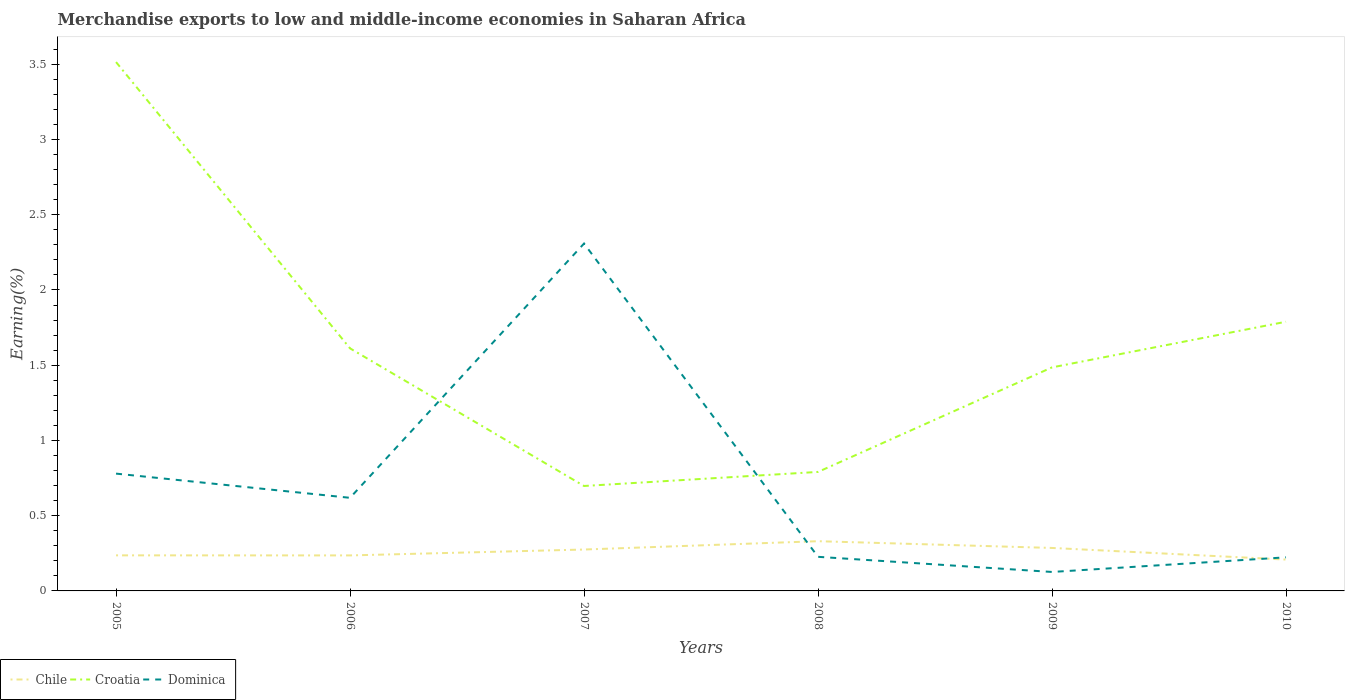How many different coloured lines are there?
Keep it short and to the point. 3. Does the line corresponding to Chile intersect with the line corresponding to Dominica?
Offer a terse response. Yes. Is the number of lines equal to the number of legend labels?
Provide a succinct answer. Yes. Across all years, what is the maximum percentage of amount earned from merchandise exports in Croatia?
Offer a very short reply. 0.7. What is the total percentage of amount earned from merchandise exports in Croatia in the graph?
Your response must be concise. -0.79. What is the difference between the highest and the second highest percentage of amount earned from merchandise exports in Chile?
Your answer should be compact. 0.12. What is the difference between the highest and the lowest percentage of amount earned from merchandise exports in Chile?
Give a very brief answer. 3. How many lines are there?
Keep it short and to the point. 3. Where does the legend appear in the graph?
Your response must be concise. Bottom left. What is the title of the graph?
Offer a very short reply. Merchandise exports to low and middle-income economies in Saharan Africa. Does "Turks and Caicos Islands" appear as one of the legend labels in the graph?
Provide a succinct answer. No. What is the label or title of the X-axis?
Offer a very short reply. Years. What is the label or title of the Y-axis?
Keep it short and to the point. Earning(%). What is the Earning(%) in Chile in 2005?
Your answer should be compact. 0.24. What is the Earning(%) in Croatia in 2005?
Your answer should be compact. 3.51. What is the Earning(%) of Dominica in 2005?
Offer a very short reply. 0.78. What is the Earning(%) in Chile in 2006?
Ensure brevity in your answer.  0.24. What is the Earning(%) of Croatia in 2006?
Offer a terse response. 1.61. What is the Earning(%) in Dominica in 2006?
Your answer should be compact. 0.62. What is the Earning(%) in Chile in 2007?
Give a very brief answer. 0.28. What is the Earning(%) in Croatia in 2007?
Offer a terse response. 0.7. What is the Earning(%) of Dominica in 2007?
Offer a terse response. 2.31. What is the Earning(%) in Chile in 2008?
Your answer should be compact. 0.33. What is the Earning(%) in Croatia in 2008?
Offer a very short reply. 0.79. What is the Earning(%) in Dominica in 2008?
Make the answer very short. 0.23. What is the Earning(%) of Chile in 2009?
Your answer should be very brief. 0.29. What is the Earning(%) in Croatia in 2009?
Your response must be concise. 1.49. What is the Earning(%) of Dominica in 2009?
Your answer should be very brief. 0.13. What is the Earning(%) in Chile in 2010?
Make the answer very short. 0.21. What is the Earning(%) in Croatia in 2010?
Your answer should be very brief. 1.79. What is the Earning(%) of Dominica in 2010?
Provide a short and direct response. 0.22. Across all years, what is the maximum Earning(%) in Chile?
Provide a succinct answer. 0.33. Across all years, what is the maximum Earning(%) in Croatia?
Offer a terse response. 3.51. Across all years, what is the maximum Earning(%) of Dominica?
Keep it short and to the point. 2.31. Across all years, what is the minimum Earning(%) of Chile?
Offer a very short reply. 0.21. Across all years, what is the minimum Earning(%) in Croatia?
Your answer should be very brief. 0.7. Across all years, what is the minimum Earning(%) of Dominica?
Ensure brevity in your answer.  0.13. What is the total Earning(%) in Chile in the graph?
Provide a short and direct response. 1.57. What is the total Earning(%) of Croatia in the graph?
Offer a very short reply. 9.89. What is the total Earning(%) of Dominica in the graph?
Offer a terse response. 4.28. What is the difference between the Earning(%) in Croatia in 2005 and that in 2006?
Keep it short and to the point. 1.9. What is the difference between the Earning(%) in Dominica in 2005 and that in 2006?
Your response must be concise. 0.16. What is the difference between the Earning(%) in Chile in 2005 and that in 2007?
Give a very brief answer. -0.04. What is the difference between the Earning(%) in Croatia in 2005 and that in 2007?
Ensure brevity in your answer.  2.82. What is the difference between the Earning(%) in Dominica in 2005 and that in 2007?
Ensure brevity in your answer.  -1.53. What is the difference between the Earning(%) of Chile in 2005 and that in 2008?
Offer a very short reply. -0.09. What is the difference between the Earning(%) in Croatia in 2005 and that in 2008?
Offer a very short reply. 2.72. What is the difference between the Earning(%) in Dominica in 2005 and that in 2008?
Offer a terse response. 0.55. What is the difference between the Earning(%) of Chile in 2005 and that in 2009?
Provide a succinct answer. -0.05. What is the difference between the Earning(%) in Croatia in 2005 and that in 2009?
Make the answer very short. 2.03. What is the difference between the Earning(%) in Dominica in 2005 and that in 2009?
Give a very brief answer. 0.65. What is the difference between the Earning(%) in Chile in 2005 and that in 2010?
Your response must be concise. 0.03. What is the difference between the Earning(%) in Croatia in 2005 and that in 2010?
Your answer should be compact. 1.73. What is the difference between the Earning(%) of Dominica in 2005 and that in 2010?
Your answer should be very brief. 0.56. What is the difference between the Earning(%) of Chile in 2006 and that in 2007?
Give a very brief answer. -0.04. What is the difference between the Earning(%) in Croatia in 2006 and that in 2007?
Give a very brief answer. 0.91. What is the difference between the Earning(%) in Dominica in 2006 and that in 2007?
Your answer should be compact. -1.69. What is the difference between the Earning(%) in Chile in 2006 and that in 2008?
Offer a very short reply. -0.09. What is the difference between the Earning(%) of Croatia in 2006 and that in 2008?
Make the answer very short. 0.82. What is the difference between the Earning(%) in Dominica in 2006 and that in 2008?
Your answer should be very brief. 0.39. What is the difference between the Earning(%) of Chile in 2006 and that in 2009?
Your answer should be very brief. -0.05. What is the difference between the Earning(%) of Croatia in 2006 and that in 2009?
Ensure brevity in your answer.  0.13. What is the difference between the Earning(%) of Dominica in 2006 and that in 2009?
Your answer should be compact. 0.49. What is the difference between the Earning(%) of Chile in 2006 and that in 2010?
Your answer should be very brief. 0.03. What is the difference between the Earning(%) in Croatia in 2006 and that in 2010?
Your response must be concise. -0.18. What is the difference between the Earning(%) of Dominica in 2006 and that in 2010?
Your response must be concise. 0.4. What is the difference between the Earning(%) of Chile in 2007 and that in 2008?
Provide a short and direct response. -0.06. What is the difference between the Earning(%) of Croatia in 2007 and that in 2008?
Give a very brief answer. -0.09. What is the difference between the Earning(%) of Dominica in 2007 and that in 2008?
Your answer should be very brief. 2.08. What is the difference between the Earning(%) in Chile in 2007 and that in 2009?
Ensure brevity in your answer.  -0.01. What is the difference between the Earning(%) in Croatia in 2007 and that in 2009?
Keep it short and to the point. -0.79. What is the difference between the Earning(%) of Dominica in 2007 and that in 2009?
Your answer should be very brief. 2.18. What is the difference between the Earning(%) in Chile in 2007 and that in 2010?
Offer a terse response. 0.07. What is the difference between the Earning(%) in Croatia in 2007 and that in 2010?
Your answer should be compact. -1.09. What is the difference between the Earning(%) in Dominica in 2007 and that in 2010?
Ensure brevity in your answer.  2.09. What is the difference between the Earning(%) in Chile in 2008 and that in 2009?
Make the answer very short. 0.04. What is the difference between the Earning(%) of Croatia in 2008 and that in 2009?
Offer a very short reply. -0.69. What is the difference between the Earning(%) in Dominica in 2008 and that in 2009?
Your answer should be very brief. 0.1. What is the difference between the Earning(%) of Chile in 2008 and that in 2010?
Offer a very short reply. 0.12. What is the difference between the Earning(%) in Croatia in 2008 and that in 2010?
Ensure brevity in your answer.  -1. What is the difference between the Earning(%) in Dominica in 2008 and that in 2010?
Your answer should be very brief. 0. What is the difference between the Earning(%) of Chile in 2009 and that in 2010?
Your answer should be very brief. 0.08. What is the difference between the Earning(%) of Croatia in 2009 and that in 2010?
Give a very brief answer. -0.3. What is the difference between the Earning(%) of Dominica in 2009 and that in 2010?
Give a very brief answer. -0.1. What is the difference between the Earning(%) of Chile in 2005 and the Earning(%) of Croatia in 2006?
Your response must be concise. -1.38. What is the difference between the Earning(%) in Chile in 2005 and the Earning(%) in Dominica in 2006?
Make the answer very short. -0.38. What is the difference between the Earning(%) in Croatia in 2005 and the Earning(%) in Dominica in 2006?
Make the answer very short. 2.9. What is the difference between the Earning(%) in Chile in 2005 and the Earning(%) in Croatia in 2007?
Provide a succinct answer. -0.46. What is the difference between the Earning(%) of Chile in 2005 and the Earning(%) of Dominica in 2007?
Provide a short and direct response. -2.07. What is the difference between the Earning(%) of Croatia in 2005 and the Earning(%) of Dominica in 2007?
Ensure brevity in your answer.  1.21. What is the difference between the Earning(%) in Chile in 2005 and the Earning(%) in Croatia in 2008?
Your answer should be very brief. -0.55. What is the difference between the Earning(%) of Chile in 2005 and the Earning(%) of Dominica in 2008?
Make the answer very short. 0.01. What is the difference between the Earning(%) of Croatia in 2005 and the Earning(%) of Dominica in 2008?
Your answer should be compact. 3.29. What is the difference between the Earning(%) in Chile in 2005 and the Earning(%) in Croatia in 2009?
Offer a terse response. -1.25. What is the difference between the Earning(%) in Chile in 2005 and the Earning(%) in Dominica in 2009?
Give a very brief answer. 0.11. What is the difference between the Earning(%) in Croatia in 2005 and the Earning(%) in Dominica in 2009?
Provide a short and direct response. 3.39. What is the difference between the Earning(%) of Chile in 2005 and the Earning(%) of Croatia in 2010?
Your answer should be very brief. -1.55. What is the difference between the Earning(%) of Chile in 2005 and the Earning(%) of Dominica in 2010?
Your answer should be very brief. 0.01. What is the difference between the Earning(%) of Croatia in 2005 and the Earning(%) of Dominica in 2010?
Ensure brevity in your answer.  3.29. What is the difference between the Earning(%) in Chile in 2006 and the Earning(%) in Croatia in 2007?
Provide a short and direct response. -0.46. What is the difference between the Earning(%) of Chile in 2006 and the Earning(%) of Dominica in 2007?
Provide a succinct answer. -2.07. What is the difference between the Earning(%) of Croatia in 2006 and the Earning(%) of Dominica in 2007?
Your response must be concise. -0.7. What is the difference between the Earning(%) in Chile in 2006 and the Earning(%) in Croatia in 2008?
Offer a very short reply. -0.55. What is the difference between the Earning(%) in Chile in 2006 and the Earning(%) in Dominica in 2008?
Your answer should be compact. 0.01. What is the difference between the Earning(%) in Croatia in 2006 and the Earning(%) in Dominica in 2008?
Make the answer very short. 1.39. What is the difference between the Earning(%) in Chile in 2006 and the Earning(%) in Croatia in 2009?
Provide a short and direct response. -1.25. What is the difference between the Earning(%) of Chile in 2006 and the Earning(%) of Dominica in 2009?
Give a very brief answer. 0.11. What is the difference between the Earning(%) of Croatia in 2006 and the Earning(%) of Dominica in 2009?
Your answer should be very brief. 1.49. What is the difference between the Earning(%) of Chile in 2006 and the Earning(%) of Croatia in 2010?
Provide a succinct answer. -1.55. What is the difference between the Earning(%) of Chile in 2006 and the Earning(%) of Dominica in 2010?
Offer a very short reply. 0.01. What is the difference between the Earning(%) in Croatia in 2006 and the Earning(%) in Dominica in 2010?
Offer a very short reply. 1.39. What is the difference between the Earning(%) of Chile in 2007 and the Earning(%) of Croatia in 2008?
Your answer should be compact. -0.52. What is the difference between the Earning(%) of Chile in 2007 and the Earning(%) of Dominica in 2008?
Your response must be concise. 0.05. What is the difference between the Earning(%) of Croatia in 2007 and the Earning(%) of Dominica in 2008?
Provide a short and direct response. 0.47. What is the difference between the Earning(%) in Chile in 2007 and the Earning(%) in Croatia in 2009?
Make the answer very short. -1.21. What is the difference between the Earning(%) in Chile in 2007 and the Earning(%) in Dominica in 2009?
Provide a succinct answer. 0.15. What is the difference between the Earning(%) of Croatia in 2007 and the Earning(%) of Dominica in 2009?
Keep it short and to the point. 0.57. What is the difference between the Earning(%) of Chile in 2007 and the Earning(%) of Croatia in 2010?
Give a very brief answer. -1.51. What is the difference between the Earning(%) in Chile in 2007 and the Earning(%) in Dominica in 2010?
Keep it short and to the point. 0.05. What is the difference between the Earning(%) in Croatia in 2007 and the Earning(%) in Dominica in 2010?
Make the answer very short. 0.47. What is the difference between the Earning(%) in Chile in 2008 and the Earning(%) in Croatia in 2009?
Offer a very short reply. -1.16. What is the difference between the Earning(%) in Chile in 2008 and the Earning(%) in Dominica in 2009?
Ensure brevity in your answer.  0.2. What is the difference between the Earning(%) in Croatia in 2008 and the Earning(%) in Dominica in 2009?
Offer a very short reply. 0.66. What is the difference between the Earning(%) of Chile in 2008 and the Earning(%) of Croatia in 2010?
Offer a very short reply. -1.46. What is the difference between the Earning(%) of Chile in 2008 and the Earning(%) of Dominica in 2010?
Your answer should be very brief. 0.11. What is the difference between the Earning(%) of Croatia in 2008 and the Earning(%) of Dominica in 2010?
Make the answer very short. 0.57. What is the difference between the Earning(%) of Chile in 2009 and the Earning(%) of Croatia in 2010?
Keep it short and to the point. -1.5. What is the difference between the Earning(%) of Chile in 2009 and the Earning(%) of Dominica in 2010?
Provide a short and direct response. 0.06. What is the difference between the Earning(%) in Croatia in 2009 and the Earning(%) in Dominica in 2010?
Make the answer very short. 1.26. What is the average Earning(%) of Chile per year?
Your answer should be very brief. 0.26. What is the average Earning(%) in Croatia per year?
Your response must be concise. 1.65. What is the average Earning(%) of Dominica per year?
Offer a terse response. 0.71. In the year 2005, what is the difference between the Earning(%) of Chile and Earning(%) of Croatia?
Ensure brevity in your answer.  -3.28. In the year 2005, what is the difference between the Earning(%) of Chile and Earning(%) of Dominica?
Provide a short and direct response. -0.54. In the year 2005, what is the difference between the Earning(%) of Croatia and Earning(%) of Dominica?
Your answer should be very brief. 2.74. In the year 2006, what is the difference between the Earning(%) in Chile and Earning(%) in Croatia?
Give a very brief answer. -1.38. In the year 2006, what is the difference between the Earning(%) in Chile and Earning(%) in Dominica?
Keep it short and to the point. -0.38. In the year 2007, what is the difference between the Earning(%) in Chile and Earning(%) in Croatia?
Offer a terse response. -0.42. In the year 2007, what is the difference between the Earning(%) in Chile and Earning(%) in Dominica?
Provide a succinct answer. -2.03. In the year 2007, what is the difference between the Earning(%) in Croatia and Earning(%) in Dominica?
Provide a succinct answer. -1.61. In the year 2008, what is the difference between the Earning(%) of Chile and Earning(%) of Croatia?
Your answer should be compact. -0.46. In the year 2008, what is the difference between the Earning(%) in Chile and Earning(%) in Dominica?
Provide a succinct answer. 0.1. In the year 2008, what is the difference between the Earning(%) of Croatia and Earning(%) of Dominica?
Give a very brief answer. 0.56. In the year 2009, what is the difference between the Earning(%) in Chile and Earning(%) in Croatia?
Your answer should be very brief. -1.2. In the year 2009, what is the difference between the Earning(%) in Chile and Earning(%) in Dominica?
Provide a short and direct response. 0.16. In the year 2009, what is the difference between the Earning(%) of Croatia and Earning(%) of Dominica?
Your answer should be compact. 1.36. In the year 2010, what is the difference between the Earning(%) in Chile and Earning(%) in Croatia?
Offer a terse response. -1.58. In the year 2010, what is the difference between the Earning(%) in Chile and Earning(%) in Dominica?
Ensure brevity in your answer.  -0.01. In the year 2010, what is the difference between the Earning(%) of Croatia and Earning(%) of Dominica?
Your answer should be compact. 1.57. What is the ratio of the Earning(%) of Chile in 2005 to that in 2006?
Your answer should be compact. 1. What is the ratio of the Earning(%) of Croatia in 2005 to that in 2006?
Keep it short and to the point. 2.18. What is the ratio of the Earning(%) of Dominica in 2005 to that in 2006?
Make the answer very short. 1.26. What is the ratio of the Earning(%) of Chile in 2005 to that in 2007?
Your answer should be compact. 0.86. What is the ratio of the Earning(%) of Croatia in 2005 to that in 2007?
Your answer should be very brief. 5.04. What is the ratio of the Earning(%) of Dominica in 2005 to that in 2007?
Ensure brevity in your answer.  0.34. What is the ratio of the Earning(%) in Chile in 2005 to that in 2008?
Provide a short and direct response. 0.72. What is the ratio of the Earning(%) in Croatia in 2005 to that in 2008?
Offer a terse response. 4.44. What is the ratio of the Earning(%) of Dominica in 2005 to that in 2008?
Provide a short and direct response. 3.44. What is the ratio of the Earning(%) in Chile in 2005 to that in 2009?
Give a very brief answer. 0.83. What is the ratio of the Earning(%) in Croatia in 2005 to that in 2009?
Keep it short and to the point. 2.37. What is the ratio of the Earning(%) in Dominica in 2005 to that in 2009?
Offer a very short reply. 6.19. What is the ratio of the Earning(%) in Chile in 2005 to that in 2010?
Give a very brief answer. 1.13. What is the ratio of the Earning(%) of Croatia in 2005 to that in 2010?
Offer a very short reply. 1.96. What is the ratio of the Earning(%) of Dominica in 2005 to that in 2010?
Keep it short and to the point. 3.49. What is the ratio of the Earning(%) in Chile in 2006 to that in 2007?
Offer a very short reply. 0.86. What is the ratio of the Earning(%) of Croatia in 2006 to that in 2007?
Keep it short and to the point. 2.31. What is the ratio of the Earning(%) in Dominica in 2006 to that in 2007?
Your answer should be very brief. 0.27. What is the ratio of the Earning(%) of Chile in 2006 to that in 2008?
Provide a succinct answer. 0.71. What is the ratio of the Earning(%) in Croatia in 2006 to that in 2008?
Offer a very short reply. 2.04. What is the ratio of the Earning(%) in Dominica in 2006 to that in 2008?
Provide a succinct answer. 2.73. What is the ratio of the Earning(%) in Chile in 2006 to that in 2009?
Ensure brevity in your answer.  0.83. What is the ratio of the Earning(%) of Croatia in 2006 to that in 2009?
Offer a terse response. 1.09. What is the ratio of the Earning(%) of Dominica in 2006 to that in 2009?
Offer a terse response. 4.91. What is the ratio of the Earning(%) of Chile in 2006 to that in 2010?
Offer a terse response. 1.13. What is the ratio of the Earning(%) of Croatia in 2006 to that in 2010?
Your answer should be very brief. 0.9. What is the ratio of the Earning(%) of Dominica in 2006 to that in 2010?
Offer a very short reply. 2.77. What is the ratio of the Earning(%) in Chile in 2007 to that in 2008?
Ensure brevity in your answer.  0.83. What is the ratio of the Earning(%) of Croatia in 2007 to that in 2008?
Give a very brief answer. 0.88. What is the ratio of the Earning(%) in Dominica in 2007 to that in 2008?
Offer a very short reply. 10.19. What is the ratio of the Earning(%) in Chile in 2007 to that in 2009?
Provide a succinct answer. 0.96. What is the ratio of the Earning(%) in Croatia in 2007 to that in 2009?
Give a very brief answer. 0.47. What is the ratio of the Earning(%) of Dominica in 2007 to that in 2009?
Offer a very short reply. 18.32. What is the ratio of the Earning(%) in Chile in 2007 to that in 2010?
Your answer should be very brief. 1.32. What is the ratio of the Earning(%) in Croatia in 2007 to that in 2010?
Make the answer very short. 0.39. What is the ratio of the Earning(%) in Dominica in 2007 to that in 2010?
Keep it short and to the point. 10.34. What is the ratio of the Earning(%) in Chile in 2008 to that in 2009?
Your response must be concise. 1.16. What is the ratio of the Earning(%) in Croatia in 2008 to that in 2009?
Your answer should be very brief. 0.53. What is the ratio of the Earning(%) in Dominica in 2008 to that in 2009?
Provide a succinct answer. 1.8. What is the ratio of the Earning(%) in Chile in 2008 to that in 2010?
Give a very brief answer. 1.59. What is the ratio of the Earning(%) of Croatia in 2008 to that in 2010?
Your answer should be compact. 0.44. What is the ratio of the Earning(%) in Dominica in 2008 to that in 2010?
Offer a very short reply. 1.01. What is the ratio of the Earning(%) of Chile in 2009 to that in 2010?
Your answer should be compact. 1.37. What is the ratio of the Earning(%) in Croatia in 2009 to that in 2010?
Offer a very short reply. 0.83. What is the ratio of the Earning(%) in Dominica in 2009 to that in 2010?
Keep it short and to the point. 0.56. What is the difference between the highest and the second highest Earning(%) in Chile?
Provide a short and direct response. 0.04. What is the difference between the highest and the second highest Earning(%) in Croatia?
Your response must be concise. 1.73. What is the difference between the highest and the second highest Earning(%) of Dominica?
Offer a terse response. 1.53. What is the difference between the highest and the lowest Earning(%) of Chile?
Make the answer very short. 0.12. What is the difference between the highest and the lowest Earning(%) of Croatia?
Your answer should be very brief. 2.82. What is the difference between the highest and the lowest Earning(%) in Dominica?
Your response must be concise. 2.18. 